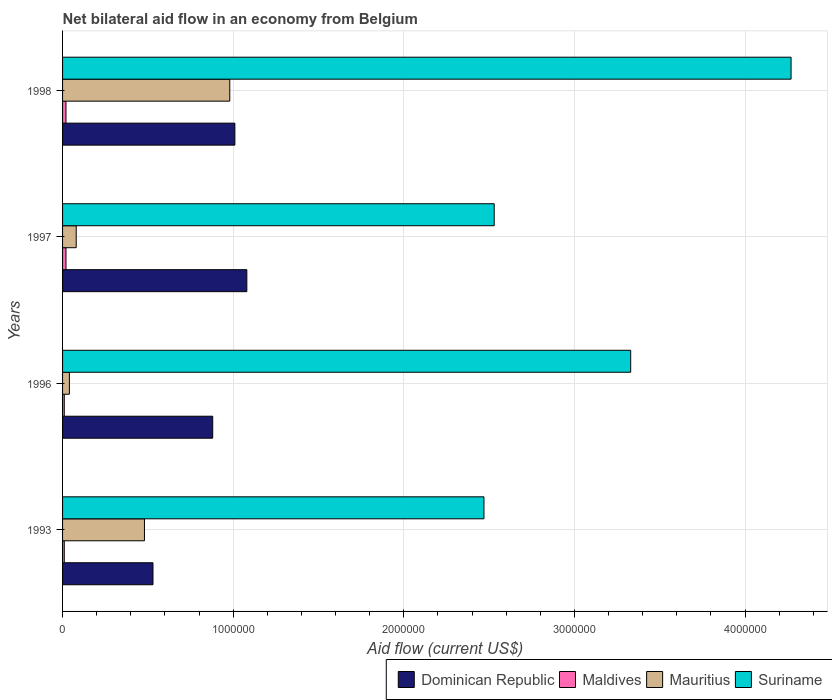How many groups of bars are there?
Your response must be concise. 4. Are the number of bars on each tick of the Y-axis equal?
Your answer should be very brief. Yes. Across all years, what is the maximum net bilateral aid flow in Mauritius?
Provide a short and direct response. 9.80e+05. Across all years, what is the minimum net bilateral aid flow in Dominican Republic?
Ensure brevity in your answer.  5.30e+05. What is the difference between the net bilateral aid flow in Mauritius in 1997 and that in 1998?
Your answer should be compact. -9.00e+05. What is the difference between the net bilateral aid flow in Mauritius in 1993 and the net bilateral aid flow in Dominican Republic in 1997?
Your response must be concise. -6.00e+05. What is the average net bilateral aid flow in Maldives per year?
Ensure brevity in your answer.  1.50e+04. In the year 1996, what is the difference between the net bilateral aid flow in Mauritius and net bilateral aid flow in Suriname?
Keep it short and to the point. -3.29e+06. What is the ratio of the net bilateral aid flow in Dominican Republic in 1993 to that in 1998?
Make the answer very short. 0.52. Is the difference between the net bilateral aid flow in Mauritius in 1997 and 1998 greater than the difference between the net bilateral aid flow in Suriname in 1997 and 1998?
Provide a short and direct response. Yes. What is the difference between the highest and the second highest net bilateral aid flow in Mauritius?
Your answer should be compact. 5.00e+05. What is the difference between the highest and the lowest net bilateral aid flow in Mauritius?
Your response must be concise. 9.40e+05. Is the sum of the net bilateral aid flow in Mauritius in 1996 and 1997 greater than the maximum net bilateral aid flow in Maldives across all years?
Your answer should be compact. Yes. Is it the case that in every year, the sum of the net bilateral aid flow in Dominican Republic and net bilateral aid flow in Maldives is greater than the sum of net bilateral aid flow in Mauritius and net bilateral aid flow in Suriname?
Your answer should be compact. No. What does the 1st bar from the top in 1996 represents?
Your answer should be compact. Suriname. What does the 3rd bar from the bottom in 1996 represents?
Offer a very short reply. Mauritius. Is it the case that in every year, the sum of the net bilateral aid flow in Maldives and net bilateral aid flow in Suriname is greater than the net bilateral aid flow in Dominican Republic?
Your response must be concise. Yes. What is the difference between two consecutive major ticks on the X-axis?
Give a very brief answer. 1.00e+06. Are the values on the major ticks of X-axis written in scientific E-notation?
Your answer should be very brief. No. Does the graph contain any zero values?
Your response must be concise. No. Where does the legend appear in the graph?
Ensure brevity in your answer.  Bottom right. How are the legend labels stacked?
Provide a succinct answer. Horizontal. What is the title of the graph?
Give a very brief answer. Net bilateral aid flow in an economy from Belgium. Does "Guinea-Bissau" appear as one of the legend labels in the graph?
Your answer should be compact. No. What is the label or title of the Y-axis?
Offer a very short reply. Years. What is the Aid flow (current US$) in Dominican Republic in 1993?
Your answer should be compact. 5.30e+05. What is the Aid flow (current US$) in Maldives in 1993?
Provide a succinct answer. 10000. What is the Aid flow (current US$) in Suriname in 1993?
Make the answer very short. 2.47e+06. What is the Aid flow (current US$) in Dominican Republic in 1996?
Offer a terse response. 8.80e+05. What is the Aid flow (current US$) of Maldives in 1996?
Keep it short and to the point. 10000. What is the Aid flow (current US$) of Mauritius in 1996?
Provide a succinct answer. 4.00e+04. What is the Aid flow (current US$) in Suriname in 1996?
Keep it short and to the point. 3.33e+06. What is the Aid flow (current US$) of Dominican Republic in 1997?
Keep it short and to the point. 1.08e+06. What is the Aid flow (current US$) in Suriname in 1997?
Provide a short and direct response. 2.53e+06. What is the Aid flow (current US$) of Dominican Republic in 1998?
Your answer should be very brief. 1.01e+06. What is the Aid flow (current US$) of Mauritius in 1998?
Your answer should be compact. 9.80e+05. What is the Aid flow (current US$) of Suriname in 1998?
Provide a succinct answer. 4.27e+06. Across all years, what is the maximum Aid flow (current US$) of Dominican Republic?
Make the answer very short. 1.08e+06. Across all years, what is the maximum Aid flow (current US$) in Maldives?
Make the answer very short. 2.00e+04. Across all years, what is the maximum Aid flow (current US$) of Mauritius?
Your response must be concise. 9.80e+05. Across all years, what is the maximum Aid flow (current US$) of Suriname?
Your answer should be compact. 4.27e+06. Across all years, what is the minimum Aid flow (current US$) of Dominican Republic?
Keep it short and to the point. 5.30e+05. Across all years, what is the minimum Aid flow (current US$) of Suriname?
Keep it short and to the point. 2.47e+06. What is the total Aid flow (current US$) of Dominican Republic in the graph?
Your response must be concise. 3.50e+06. What is the total Aid flow (current US$) of Mauritius in the graph?
Your response must be concise. 1.58e+06. What is the total Aid flow (current US$) in Suriname in the graph?
Your answer should be compact. 1.26e+07. What is the difference between the Aid flow (current US$) in Dominican Republic in 1993 and that in 1996?
Offer a very short reply. -3.50e+05. What is the difference between the Aid flow (current US$) in Mauritius in 1993 and that in 1996?
Provide a short and direct response. 4.40e+05. What is the difference between the Aid flow (current US$) of Suriname in 1993 and that in 1996?
Offer a very short reply. -8.60e+05. What is the difference between the Aid flow (current US$) of Dominican Republic in 1993 and that in 1997?
Your response must be concise. -5.50e+05. What is the difference between the Aid flow (current US$) in Mauritius in 1993 and that in 1997?
Your response must be concise. 4.00e+05. What is the difference between the Aid flow (current US$) of Suriname in 1993 and that in 1997?
Your answer should be very brief. -6.00e+04. What is the difference between the Aid flow (current US$) of Dominican Republic in 1993 and that in 1998?
Provide a short and direct response. -4.80e+05. What is the difference between the Aid flow (current US$) of Maldives in 1993 and that in 1998?
Make the answer very short. -10000. What is the difference between the Aid flow (current US$) in Mauritius in 1993 and that in 1998?
Keep it short and to the point. -5.00e+05. What is the difference between the Aid flow (current US$) in Suriname in 1993 and that in 1998?
Give a very brief answer. -1.80e+06. What is the difference between the Aid flow (current US$) of Maldives in 1996 and that in 1997?
Your answer should be very brief. -10000. What is the difference between the Aid flow (current US$) in Suriname in 1996 and that in 1997?
Your answer should be compact. 8.00e+05. What is the difference between the Aid flow (current US$) in Dominican Republic in 1996 and that in 1998?
Provide a short and direct response. -1.30e+05. What is the difference between the Aid flow (current US$) in Mauritius in 1996 and that in 1998?
Provide a succinct answer. -9.40e+05. What is the difference between the Aid flow (current US$) in Suriname in 1996 and that in 1998?
Make the answer very short. -9.40e+05. What is the difference between the Aid flow (current US$) of Dominican Republic in 1997 and that in 1998?
Make the answer very short. 7.00e+04. What is the difference between the Aid flow (current US$) of Mauritius in 1997 and that in 1998?
Offer a very short reply. -9.00e+05. What is the difference between the Aid flow (current US$) of Suriname in 1997 and that in 1998?
Provide a short and direct response. -1.74e+06. What is the difference between the Aid flow (current US$) of Dominican Republic in 1993 and the Aid flow (current US$) of Maldives in 1996?
Keep it short and to the point. 5.20e+05. What is the difference between the Aid flow (current US$) of Dominican Republic in 1993 and the Aid flow (current US$) of Mauritius in 1996?
Provide a succinct answer. 4.90e+05. What is the difference between the Aid flow (current US$) in Dominican Republic in 1993 and the Aid flow (current US$) in Suriname in 1996?
Give a very brief answer. -2.80e+06. What is the difference between the Aid flow (current US$) in Maldives in 1993 and the Aid flow (current US$) in Suriname in 1996?
Give a very brief answer. -3.32e+06. What is the difference between the Aid flow (current US$) of Mauritius in 1993 and the Aid flow (current US$) of Suriname in 1996?
Offer a very short reply. -2.85e+06. What is the difference between the Aid flow (current US$) of Dominican Republic in 1993 and the Aid flow (current US$) of Maldives in 1997?
Your answer should be compact. 5.10e+05. What is the difference between the Aid flow (current US$) of Dominican Republic in 1993 and the Aid flow (current US$) of Mauritius in 1997?
Ensure brevity in your answer.  4.50e+05. What is the difference between the Aid flow (current US$) in Dominican Republic in 1993 and the Aid flow (current US$) in Suriname in 1997?
Your answer should be compact. -2.00e+06. What is the difference between the Aid flow (current US$) in Maldives in 1993 and the Aid flow (current US$) in Mauritius in 1997?
Offer a terse response. -7.00e+04. What is the difference between the Aid flow (current US$) of Maldives in 1993 and the Aid flow (current US$) of Suriname in 1997?
Ensure brevity in your answer.  -2.52e+06. What is the difference between the Aid flow (current US$) in Mauritius in 1993 and the Aid flow (current US$) in Suriname in 1997?
Offer a terse response. -2.05e+06. What is the difference between the Aid flow (current US$) of Dominican Republic in 1993 and the Aid flow (current US$) of Maldives in 1998?
Offer a very short reply. 5.10e+05. What is the difference between the Aid flow (current US$) in Dominican Republic in 1993 and the Aid flow (current US$) in Mauritius in 1998?
Give a very brief answer. -4.50e+05. What is the difference between the Aid flow (current US$) in Dominican Republic in 1993 and the Aid flow (current US$) in Suriname in 1998?
Provide a short and direct response. -3.74e+06. What is the difference between the Aid flow (current US$) in Maldives in 1993 and the Aid flow (current US$) in Mauritius in 1998?
Your answer should be very brief. -9.70e+05. What is the difference between the Aid flow (current US$) of Maldives in 1993 and the Aid flow (current US$) of Suriname in 1998?
Offer a very short reply. -4.26e+06. What is the difference between the Aid flow (current US$) of Mauritius in 1993 and the Aid flow (current US$) of Suriname in 1998?
Your response must be concise. -3.79e+06. What is the difference between the Aid flow (current US$) in Dominican Republic in 1996 and the Aid flow (current US$) in Maldives in 1997?
Offer a very short reply. 8.60e+05. What is the difference between the Aid flow (current US$) in Dominican Republic in 1996 and the Aid flow (current US$) in Suriname in 1997?
Make the answer very short. -1.65e+06. What is the difference between the Aid flow (current US$) in Maldives in 1996 and the Aid flow (current US$) in Mauritius in 1997?
Your answer should be compact. -7.00e+04. What is the difference between the Aid flow (current US$) in Maldives in 1996 and the Aid flow (current US$) in Suriname in 1997?
Provide a succinct answer. -2.52e+06. What is the difference between the Aid flow (current US$) of Mauritius in 1996 and the Aid flow (current US$) of Suriname in 1997?
Provide a short and direct response. -2.49e+06. What is the difference between the Aid flow (current US$) of Dominican Republic in 1996 and the Aid flow (current US$) of Maldives in 1998?
Your answer should be compact. 8.60e+05. What is the difference between the Aid flow (current US$) in Dominican Republic in 1996 and the Aid flow (current US$) in Suriname in 1998?
Your answer should be compact. -3.39e+06. What is the difference between the Aid flow (current US$) of Maldives in 1996 and the Aid flow (current US$) of Mauritius in 1998?
Provide a short and direct response. -9.70e+05. What is the difference between the Aid flow (current US$) of Maldives in 1996 and the Aid flow (current US$) of Suriname in 1998?
Keep it short and to the point. -4.26e+06. What is the difference between the Aid flow (current US$) in Mauritius in 1996 and the Aid flow (current US$) in Suriname in 1998?
Offer a terse response. -4.23e+06. What is the difference between the Aid flow (current US$) in Dominican Republic in 1997 and the Aid flow (current US$) in Maldives in 1998?
Your answer should be compact. 1.06e+06. What is the difference between the Aid flow (current US$) in Dominican Republic in 1997 and the Aid flow (current US$) in Suriname in 1998?
Keep it short and to the point. -3.19e+06. What is the difference between the Aid flow (current US$) of Maldives in 1997 and the Aid flow (current US$) of Mauritius in 1998?
Keep it short and to the point. -9.60e+05. What is the difference between the Aid flow (current US$) in Maldives in 1997 and the Aid flow (current US$) in Suriname in 1998?
Your answer should be compact. -4.25e+06. What is the difference between the Aid flow (current US$) of Mauritius in 1997 and the Aid flow (current US$) of Suriname in 1998?
Your answer should be very brief. -4.19e+06. What is the average Aid flow (current US$) of Dominican Republic per year?
Your answer should be compact. 8.75e+05. What is the average Aid flow (current US$) in Maldives per year?
Your answer should be very brief. 1.50e+04. What is the average Aid flow (current US$) in Mauritius per year?
Make the answer very short. 3.95e+05. What is the average Aid flow (current US$) of Suriname per year?
Make the answer very short. 3.15e+06. In the year 1993, what is the difference between the Aid flow (current US$) of Dominican Republic and Aid flow (current US$) of Maldives?
Offer a terse response. 5.20e+05. In the year 1993, what is the difference between the Aid flow (current US$) of Dominican Republic and Aid flow (current US$) of Suriname?
Make the answer very short. -1.94e+06. In the year 1993, what is the difference between the Aid flow (current US$) of Maldives and Aid flow (current US$) of Mauritius?
Offer a very short reply. -4.70e+05. In the year 1993, what is the difference between the Aid flow (current US$) of Maldives and Aid flow (current US$) of Suriname?
Give a very brief answer. -2.46e+06. In the year 1993, what is the difference between the Aid flow (current US$) of Mauritius and Aid flow (current US$) of Suriname?
Offer a very short reply. -1.99e+06. In the year 1996, what is the difference between the Aid flow (current US$) in Dominican Republic and Aid flow (current US$) in Maldives?
Keep it short and to the point. 8.70e+05. In the year 1996, what is the difference between the Aid flow (current US$) in Dominican Republic and Aid flow (current US$) in Mauritius?
Ensure brevity in your answer.  8.40e+05. In the year 1996, what is the difference between the Aid flow (current US$) of Dominican Republic and Aid flow (current US$) of Suriname?
Give a very brief answer. -2.45e+06. In the year 1996, what is the difference between the Aid flow (current US$) in Maldives and Aid flow (current US$) in Mauritius?
Your response must be concise. -3.00e+04. In the year 1996, what is the difference between the Aid flow (current US$) of Maldives and Aid flow (current US$) of Suriname?
Offer a very short reply. -3.32e+06. In the year 1996, what is the difference between the Aid flow (current US$) in Mauritius and Aid flow (current US$) in Suriname?
Offer a very short reply. -3.29e+06. In the year 1997, what is the difference between the Aid flow (current US$) in Dominican Republic and Aid flow (current US$) in Maldives?
Give a very brief answer. 1.06e+06. In the year 1997, what is the difference between the Aid flow (current US$) of Dominican Republic and Aid flow (current US$) of Mauritius?
Your answer should be very brief. 1.00e+06. In the year 1997, what is the difference between the Aid flow (current US$) in Dominican Republic and Aid flow (current US$) in Suriname?
Provide a short and direct response. -1.45e+06. In the year 1997, what is the difference between the Aid flow (current US$) of Maldives and Aid flow (current US$) of Suriname?
Your answer should be compact. -2.51e+06. In the year 1997, what is the difference between the Aid flow (current US$) of Mauritius and Aid flow (current US$) of Suriname?
Offer a very short reply. -2.45e+06. In the year 1998, what is the difference between the Aid flow (current US$) in Dominican Republic and Aid flow (current US$) in Maldives?
Your response must be concise. 9.90e+05. In the year 1998, what is the difference between the Aid flow (current US$) of Dominican Republic and Aid flow (current US$) of Suriname?
Provide a succinct answer. -3.26e+06. In the year 1998, what is the difference between the Aid flow (current US$) of Maldives and Aid flow (current US$) of Mauritius?
Keep it short and to the point. -9.60e+05. In the year 1998, what is the difference between the Aid flow (current US$) in Maldives and Aid flow (current US$) in Suriname?
Offer a terse response. -4.25e+06. In the year 1998, what is the difference between the Aid flow (current US$) in Mauritius and Aid flow (current US$) in Suriname?
Make the answer very short. -3.29e+06. What is the ratio of the Aid flow (current US$) in Dominican Republic in 1993 to that in 1996?
Your answer should be compact. 0.6. What is the ratio of the Aid flow (current US$) of Mauritius in 1993 to that in 1996?
Your answer should be very brief. 12. What is the ratio of the Aid flow (current US$) of Suriname in 1993 to that in 1996?
Keep it short and to the point. 0.74. What is the ratio of the Aid flow (current US$) in Dominican Republic in 1993 to that in 1997?
Your answer should be compact. 0.49. What is the ratio of the Aid flow (current US$) of Maldives in 1993 to that in 1997?
Offer a terse response. 0.5. What is the ratio of the Aid flow (current US$) of Mauritius in 1993 to that in 1997?
Ensure brevity in your answer.  6. What is the ratio of the Aid flow (current US$) in Suriname in 1993 to that in 1997?
Offer a terse response. 0.98. What is the ratio of the Aid flow (current US$) in Dominican Republic in 1993 to that in 1998?
Provide a succinct answer. 0.52. What is the ratio of the Aid flow (current US$) in Mauritius in 1993 to that in 1998?
Provide a succinct answer. 0.49. What is the ratio of the Aid flow (current US$) of Suriname in 1993 to that in 1998?
Make the answer very short. 0.58. What is the ratio of the Aid flow (current US$) in Dominican Republic in 1996 to that in 1997?
Ensure brevity in your answer.  0.81. What is the ratio of the Aid flow (current US$) of Maldives in 1996 to that in 1997?
Keep it short and to the point. 0.5. What is the ratio of the Aid flow (current US$) in Mauritius in 1996 to that in 1997?
Keep it short and to the point. 0.5. What is the ratio of the Aid flow (current US$) in Suriname in 1996 to that in 1997?
Give a very brief answer. 1.32. What is the ratio of the Aid flow (current US$) in Dominican Republic in 1996 to that in 1998?
Your answer should be compact. 0.87. What is the ratio of the Aid flow (current US$) in Maldives in 1996 to that in 1998?
Keep it short and to the point. 0.5. What is the ratio of the Aid flow (current US$) in Mauritius in 1996 to that in 1998?
Give a very brief answer. 0.04. What is the ratio of the Aid flow (current US$) of Suriname in 1996 to that in 1998?
Ensure brevity in your answer.  0.78. What is the ratio of the Aid flow (current US$) of Dominican Republic in 1997 to that in 1998?
Ensure brevity in your answer.  1.07. What is the ratio of the Aid flow (current US$) in Maldives in 1997 to that in 1998?
Provide a short and direct response. 1. What is the ratio of the Aid flow (current US$) in Mauritius in 1997 to that in 1998?
Your answer should be very brief. 0.08. What is the ratio of the Aid flow (current US$) of Suriname in 1997 to that in 1998?
Your answer should be compact. 0.59. What is the difference between the highest and the second highest Aid flow (current US$) in Suriname?
Make the answer very short. 9.40e+05. What is the difference between the highest and the lowest Aid flow (current US$) in Mauritius?
Offer a terse response. 9.40e+05. What is the difference between the highest and the lowest Aid flow (current US$) of Suriname?
Your answer should be compact. 1.80e+06. 